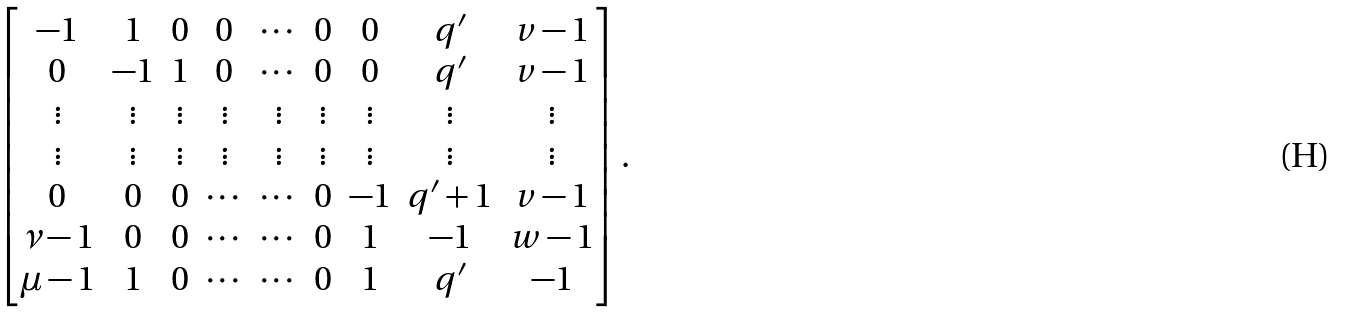<formula> <loc_0><loc_0><loc_500><loc_500>\begin{bmatrix} - 1 & 1 & 0 & 0 & \cdots & 0 & 0 & q ^ { \prime } & v - 1 \\ 0 & - 1 & 1 & 0 & \cdots & 0 & 0 & q ^ { \prime } & v - 1 \\ \vdots & \vdots & \vdots & \vdots & \vdots & \vdots & \vdots & \vdots & \vdots \\ \vdots & \vdots & \vdots & \vdots & \vdots & \vdots & \vdots & \vdots & \vdots \\ 0 & 0 & 0 & \cdots & \cdots & 0 & - 1 & q ^ { \prime } + 1 & v - 1 \\ \nu - 1 & 0 & 0 & \cdots & \cdots & 0 & 1 & - 1 & w - 1 \\ \mu - 1 & 1 & 0 & \cdots & \cdots & 0 & 1 & q ^ { \prime } & - 1 \end{bmatrix} .</formula> 